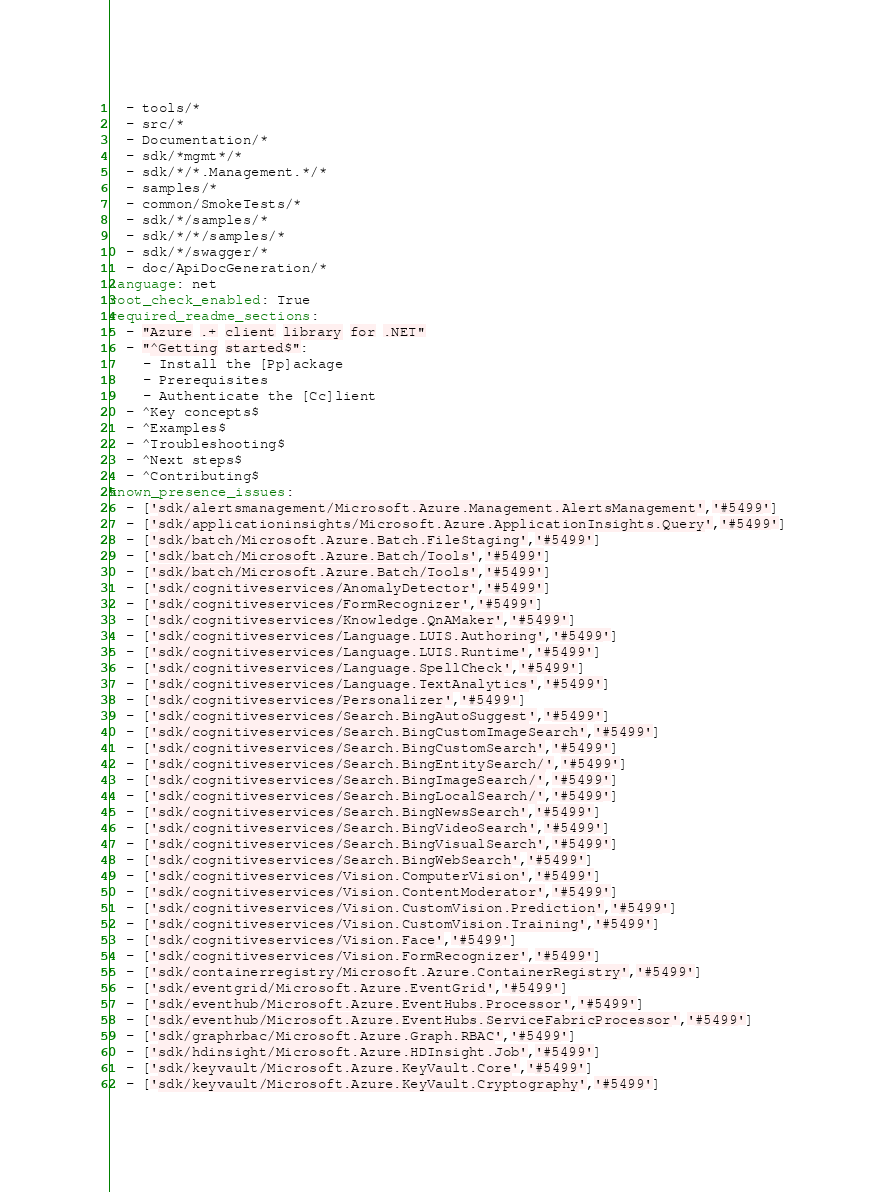Convert code to text. <code><loc_0><loc_0><loc_500><loc_500><_YAML_>  - tools/*
  - src/*
  - Documentation/*
  - sdk/*mgmt*/*
  - sdk/*/*.Management.*/*
  - samples/*
  - common/SmokeTests/*
  - sdk/*/samples/*
  - sdk/*/*/samples/*
  - sdk/*/swagger/*
  - doc/ApiDocGeneration/*
language: net
root_check_enabled: True
required_readme_sections:
  - "Azure .+ client library for .NET"
  - "^Getting started$":
    - Install the [Pp]ackage
    - Prerequisites
    - Authenticate the [Cc]lient
  - ^Key concepts$
  - ^Examples$
  - ^Troubleshooting$
  - ^Next steps$
  - ^Contributing$
known_presence_issues:
  - ['sdk/alertsmanagement/Microsoft.Azure.Management.AlertsManagement','#5499']
  - ['sdk/applicationinsights/Microsoft.Azure.ApplicationInsights.Query','#5499']
  - ['sdk/batch/Microsoft.Azure.Batch.FileStaging','#5499']
  - ['sdk/batch/Microsoft.Azure.Batch/Tools','#5499']
  - ['sdk/batch/Microsoft.Azure.Batch/Tools','#5499']
  - ['sdk/cognitiveservices/AnomalyDetector','#5499']
  - ['sdk/cognitiveservices/FormRecognizer','#5499']
  - ['sdk/cognitiveservices/Knowledge.QnAMaker','#5499']
  - ['sdk/cognitiveservices/Language.LUIS.Authoring','#5499']
  - ['sdk/cognitiveservices/Language.LUIS.Runtime','#5499']
  - ['sdk/cognitiveservices/Language.SpellCheck','#5499']
  - ['sdk/cognitiveservices/Language.TextAnalytics','#5499']
  - ['sdk/cognitiveservices/Personalizer','#5499']
  - ['sdk/cognitiveservices/Search.BingAutoSuggest','#5499']
  - ['sdk/cognitiveservices/Search.BingCustomImageSearch','#5499']
  - ['sdk/cognitiveservices/Search.BingCustomSearch','#5499']
  - ['sdk/cognitiveservices/Search.BingEntitySearch/','#5499']
  - ['sdk/cognitiveservices/Search.BingImageSearch/','#5499']
  - ['sdk/cognitiveservices/Search.BingLocalSearch/','#5499']
  - ['sdk/cognitiveservices/Search.BingNewsSearch','#5499']
  - ['sdk/cognitiveservices/Search.BingVideoSearch','#5499']
  - ['sdk/cognitiveservices/Search.BingVisualSearch','#5499']
  - ['sdk/cognitiveservices/Search.BingWebSearch','#5499']
  - ['sdk/cognitiveservices/Vision.ComputerVision','#5499']
  - ['sdk/cognitiveservices/Vision.ContentModerator','#5499']
  - ['sdk/cognitiveservices/Vision.CustomVision.Prediction','#5499']
  - ['sdk/cognitiveservices/Vision.CustomVision.Training','#5499']
  - ['sdk/cognitiveservices/Vision.Face','#5499']
  - ['sdk/cognitiveservices/Vision.FormRecognizer','#5499']
  - ['sdk/containerregistry/Microsoft.Azure.ContainerRegistry','#5499']
  - ['sdk/eventgrid/Microsoft.Azure.EventGrid','#5499']
  - ['sdk/eventhub/Microsoft.Azure.EventHubs.Processor','#5499']
  - ['sdk/eventhub/Microsoft.Azure.EventHubs.ServiceFabricProcessor','#5499']
  - ['sdk/graphrbac/Microsoft.Azure.Graph.RBAC','#5499']
  - ['sdk/hdinsight/Microsoft.Azure.HDInsight.Job','#5499']
  - ['sdk/keyvault/Microsoft.Azure.KeyVault.Core','#5499']
  - ['sdk/keyvault/Microsoft.Azure.KeyVault.Cryptography','#5499']</code> 